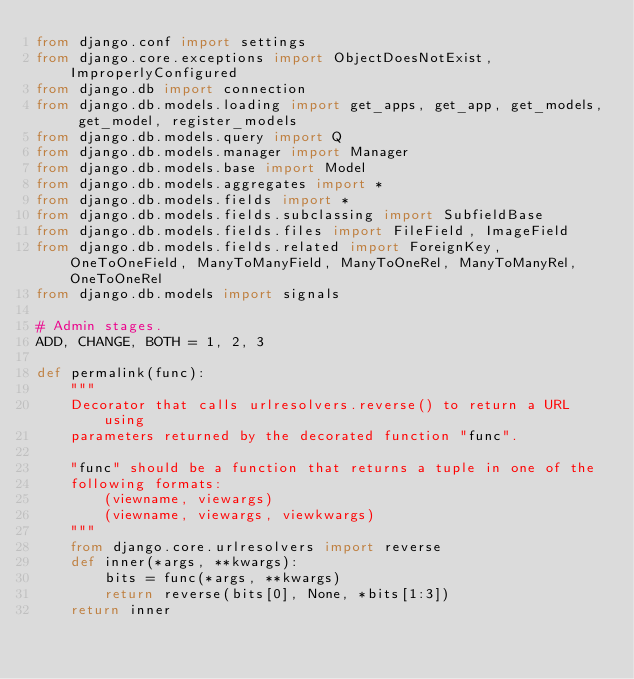Convert code to text. <code><loc_0><loc_0><loc_500><loc_500><_Python_>from django.conf import settings
from django.core.exceptions import ObjectDoesNotExist, ImproperlyConfigured
from django.db import connection
from django.db.models.loading import get_apps, get_app, get_models, get_model, register_models
from django.db.models.query import Q
from django.db.models.manager import Manager
from django.db.models.base import Model
from django.db.models.aggregates import *
from django.db.models.fields import *
from django.db.models.fields.subclassing import SubfieldBase
from django.db.models.fields.files import FileField, ImageField
from django.db.models.fields.related import ForeignKey, OneToOneField, ManyToManyField, ManyToOneRel, ManyToManyRel, OneToOneRel
from django.db.models import signals

# Admin stages.
ADD, CHANGE, BOTH = 1, 2, 3

def permalink(func):
    """
    Decorator that calls urlresolvers.reverse() to return a URL using
    parameters returned by the decorated function "func".

    "func" should be a function that returns a tuple in one of the
    following formats:
        (viewname, viewargs)
        (viewname, viewargs, viewkwargs)
    """
    from django.core.urlresolvers import reverse
    def inner(*args, **kwargs):
        bits = func(*args, **kwargs)
        return reverse(bits[0], None, *bits[1:3])
    return inner
</code> 